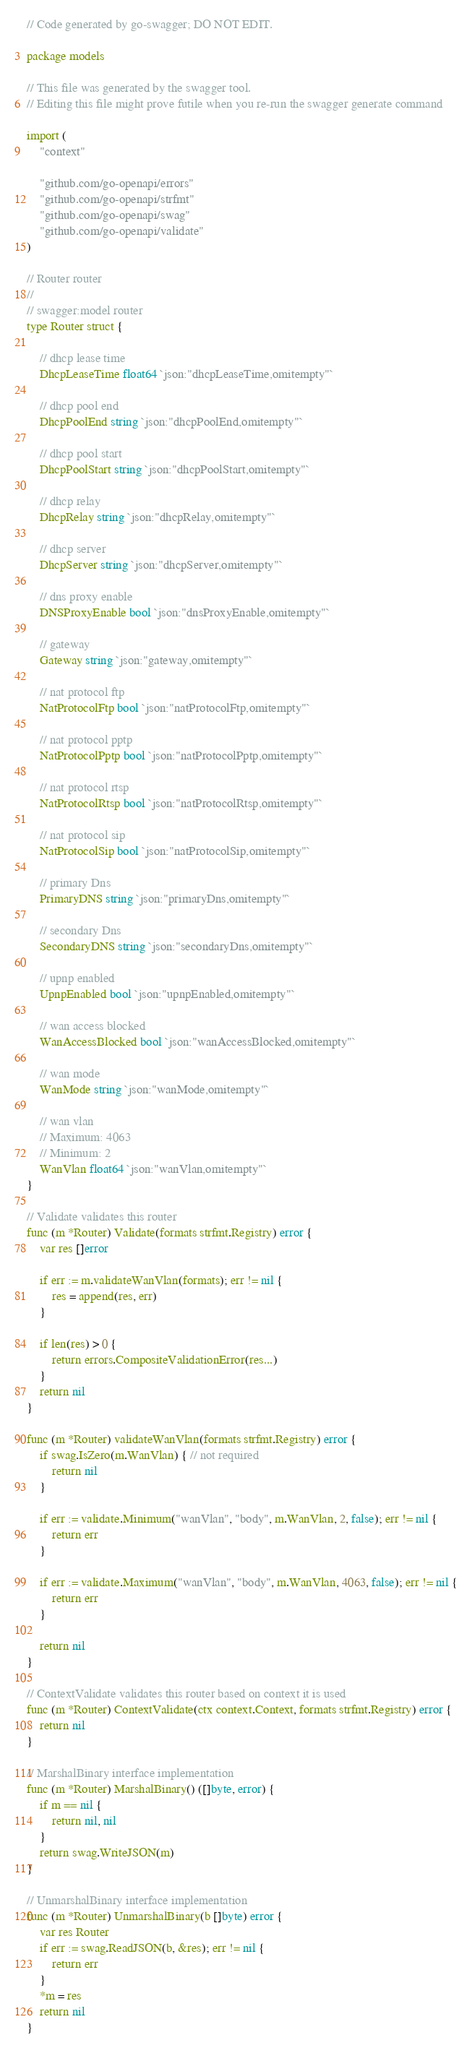Convert code to text. <code><loc_0><loc_0><loc_500><loc_500><_Go_>// Code generated by go-swagger; DO NOT EDIT.

package models

// This file was generated by the swagger tool.
// Editing this file might prove futile when you re-run the swagger generate command

import (
	"context"

	"github.com/go-openapi/errors"
	"github.com/go-openapi/strfmt"
	"github.com/go-openapi/swag"
	"github.com/go-openapi/validate"
)

// Router router
//
// swagger:model router
type Router struct {

	// dhcp lease time
	DhcpLeaseTime float64 `json:"dhcpLeaseTime,omitempty"`

	// dhcp pool end
	DhcpPoolEnd string `json:"dhcpPoolEnd,omitempty"`

	// dhcp pool start
	DhcpPoolStart string `json:"dhcpPoolStart,omitempty"`

	// dhcp relay
	DhcpRelay string `json:"dhcpRelay,omitempty"`

	// dhcp server
	DhcpServer string `json:"dhcpServer,omitempty"`

	// dns proxy enable
	DNSProxyEnable bool `json:"dnsProxyEnable,omitempty"`

	// gateway
	Gateway string `json:"gateway,omitempty"`

	// nat protocol ftp
	NatProtocolFtp bool `json:"natProtocolFtp,omitempty"`

	// nat protocol pptp
	NatProtocolPptp bool `json:"natProtocolPptp,omitempty"`

	// nat protocol rtsp
	NatProtocolRtsp bool `json:"natProtocolRtsp,omitempty"`

	// nat protocol sip
	NatProtocolSip bool `json:"natProtocolSip,omitempty"`

	// primary Dns
	PrimaryDNS string `json:"primaryDns,omitempty"`

	// secondary Dns
	SecondaryDNS string `json:"secondaryDns,omitempty"`

	// upnp enabled
	UpnpEnabled bool `json:"upnpEnabled,omitempty"`

	// wan access blocked
	WanAccessBlocked bool `json:"wanAccessBlocked,omitempty"`

	// wan mode
	WanMode string `json:"wanMode,omitempty"`

	// wan vlan
	// Maximum: 4063
	// Minimum: 2
	WanVlan float64 `json:"wanVlan,omitempty"`
}

// Validate validates this router
func (m *Router) Validate(formats strfmt.Registry) error {
	var res []error

	if err := m.validateWanVlan(formats); err != nil {
		res = append(res, err)
	}

	if len(res) > 0 {
		return errors.CompositeValidationError(res...)
	}
	return nil
}

func (m *Router) validateWanVlan(formats strfmt.Registry) error {
	if swag.IsZero(m.WanVlan) { // not required
		return nil
	}

	if err := validate.Minimum("wanVlan", "body", m.WanVlan, 2, false); err != nil {
		return err
	}

	if err := validate.Maximum("wanVlan", "body", m.WanVlan, 4063, false); err != nil {
		return err
	}

	return nil
}

// ContextValidate validates this router based on context it is used
func (m *Router) ContextValidate(ctx context.Context, formats strfmt.Registry) error {
	return nil
}

// MarshalBinary interface implementation
func (m *Router) MarshalBinary() ([]byte, error) {
	if m == nil {
		return nil, nil
	}
	return swag.WriteJSON(m)
}

// UnmarshalBinary interface implementation
func (m *Router) UnmarshalBinary(b []byte) error {
	var res Router
	if err := swag.ReadJSON(b, &res); err != nil {
		return err
	}
	*m = res
	return nil
}
</code> 